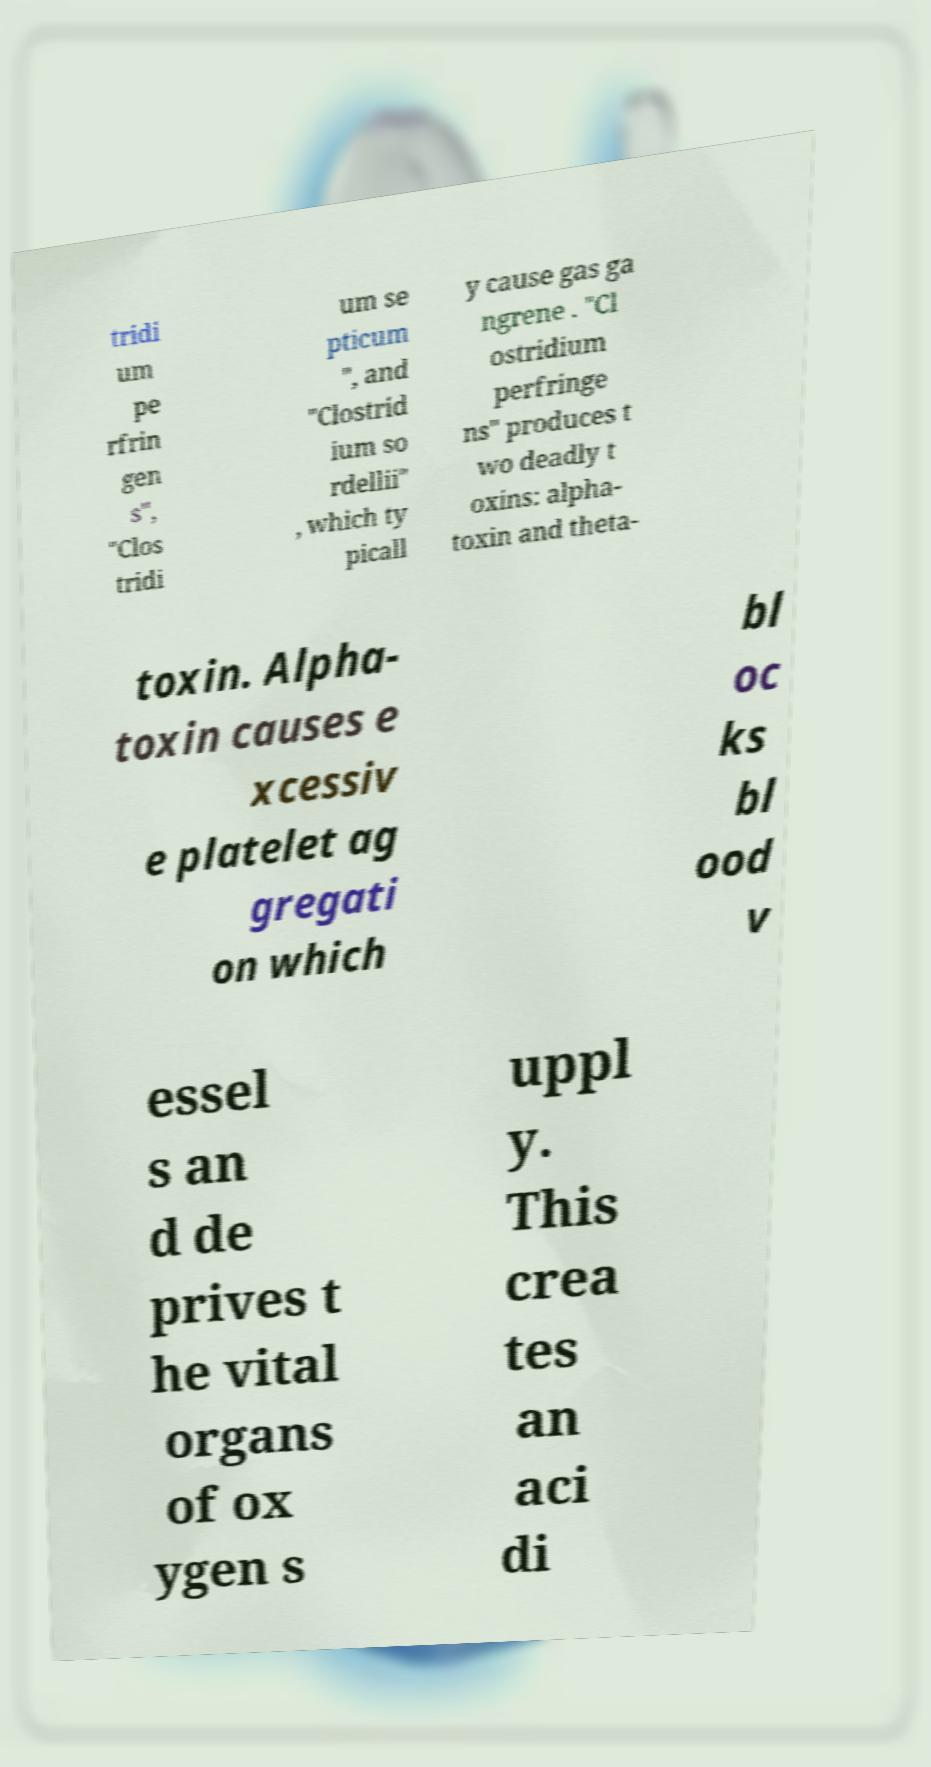Could you assist in decoding the text presented in this image and type it out clearly? tridi um pe rfrin gen s", "Clos tridi um se pticum ", and "Clostrid ium so rdellii" , which ty picall y cause gas ga ngrene . "Cl ostridium perfringe ns" produces t wo deadly t oxins: alpha- toxin and theta- toxin. Alpha- toxin causes e xcessiv e platelet ag gregati on which bl oc ks bl ood v essel s an d de prives t he vital organs of ox ygen s uppl y. This crea tes an aci di 